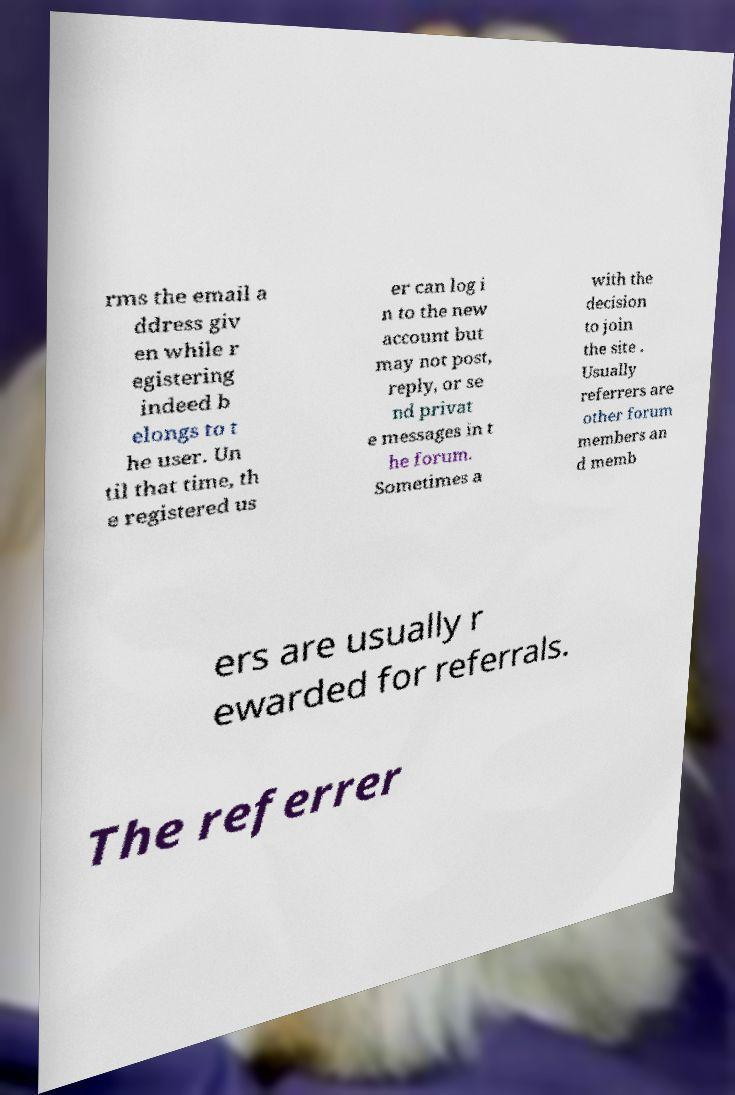What messages or text are displayed in this image? I need them in a readable, typed format. rms the email a ddress giv en while r egistering indeed b elongs to t he user. Un til that time, th e registered us er can log i n to the new account but may not post, reply, or se nd privat e messages in t he forum. Sometimes a with the decision to join the site . Usually referrers are other forum members an d memb ers are usually r ewarded for referrals. The referrer 